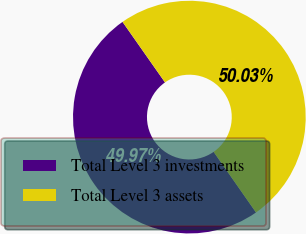Convert chart. <chart><loc_0><loc_0><loc_500><loc_500><pie_chart><fcel>Total Level 3 investments<fcel>Total Level 3 assets<nl><fcel>49.97%<fcel>50.03%<nl></chart> 